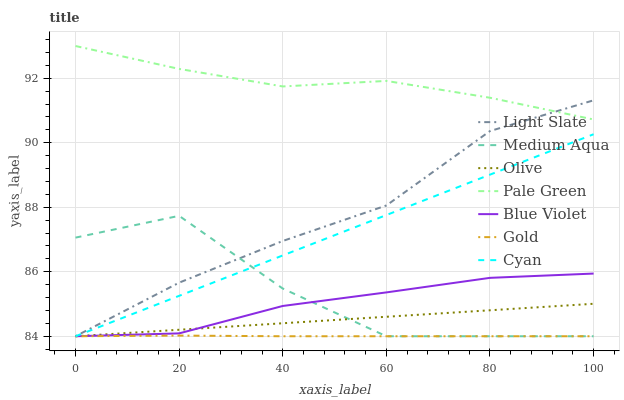Does Gold have the minimum area under the curve?
Answer yes or no. Yes. Does Pale Green have the maximum area under the curve?
Answer yes or no. Yes. Does Light Slate have the minimum area under the curve?
Answer yes or no. No. Does Light Slate have the maximum area under the curve?
Answer yes or no. No. Is Olive the smoothest?
Answer yes or no. Yes. Is Medium Aqua the roughest?
Answer yes or no. Yes. Is Light Slate the smoothest?
Answer yes or no. No. Is Light Slate the roughest?
Answer yes or no. No. Does Gold have the lowest value?
Answer yes or no. Yes. Does Pale Green have the lowest value?
Answer yes or no. No. Does Pale Green have the highest value?
Answer yes or no. Yes. Does Light Slate have the highest value?
Answer yes or no. No. Is Blue Violet less than Pale Green?
Answer yes or no. Yes. Is Pale Green greater than Blue Violet?
Answer yes or no. Yes. Does Cyan intersect Medium Aqua?
Answer yes or no. Yes. Is Cyan less than Medium Aqua?
Answer yes or no. No. Is Cyan greater than Medium Aqua?
Answer yes or no. No. Does Blue Violet intersect Pale Green?
Answer yes or no. No. 